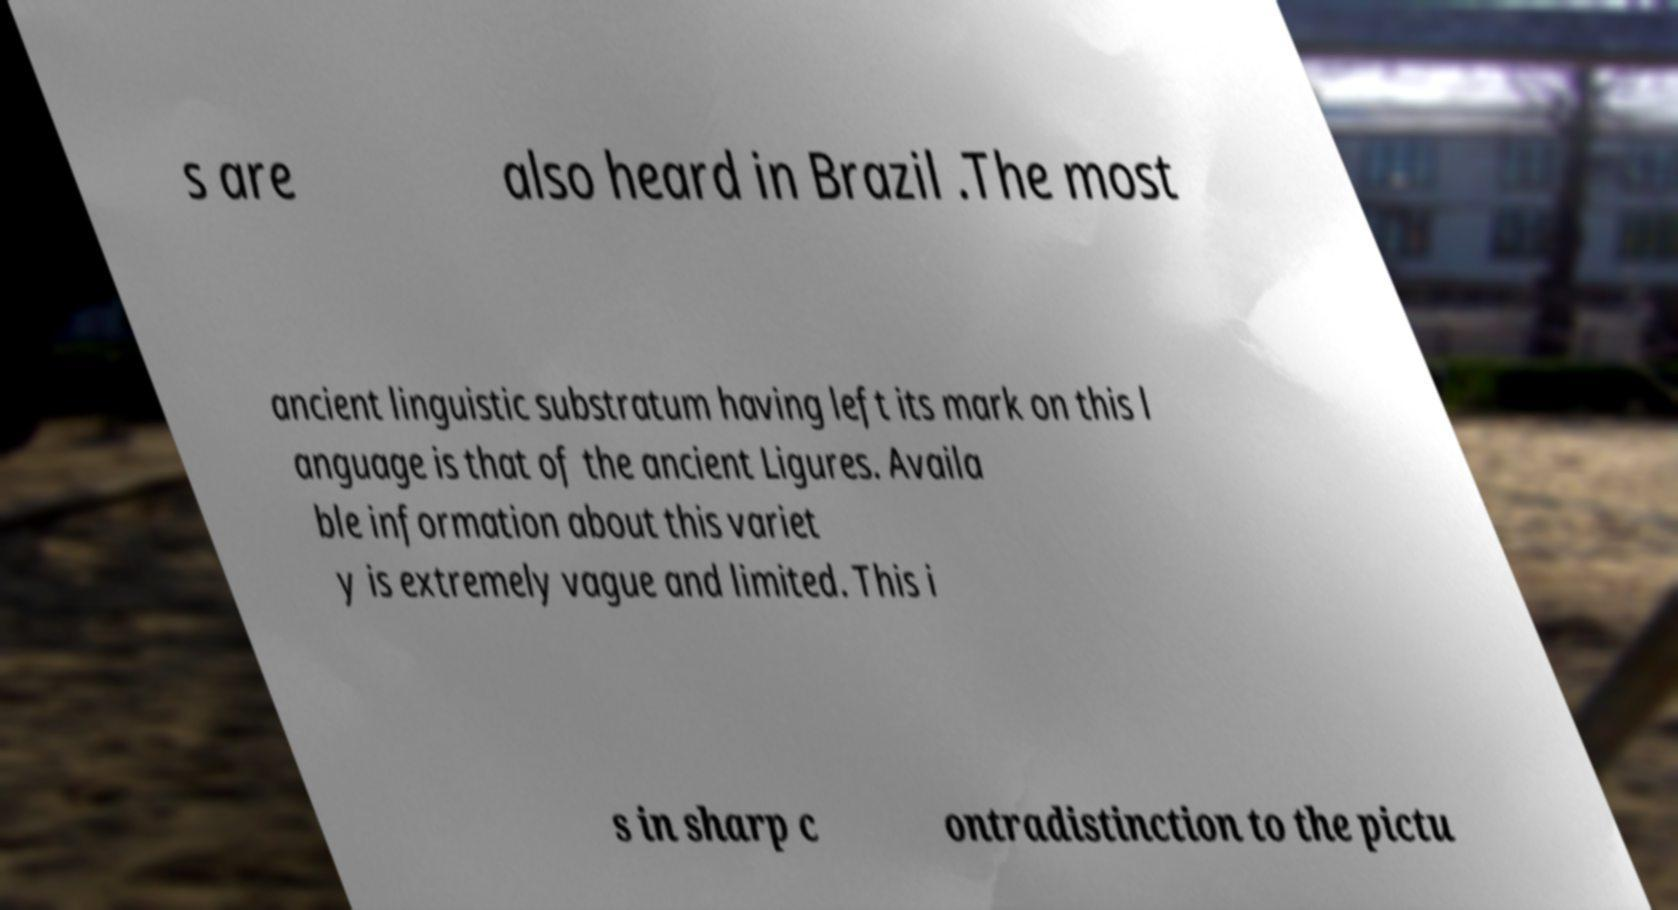There's text embedded in this image that I need extracted. Can you transcribe it verbatim? s are also heard in Brazil .The most ancient linguistic substratum having left its mark on this l anguage is that of the ancient Ligures. Availa ble information about this variet y is extremely vague and limited. This i s in sharp c ontradistinction to the pictu 